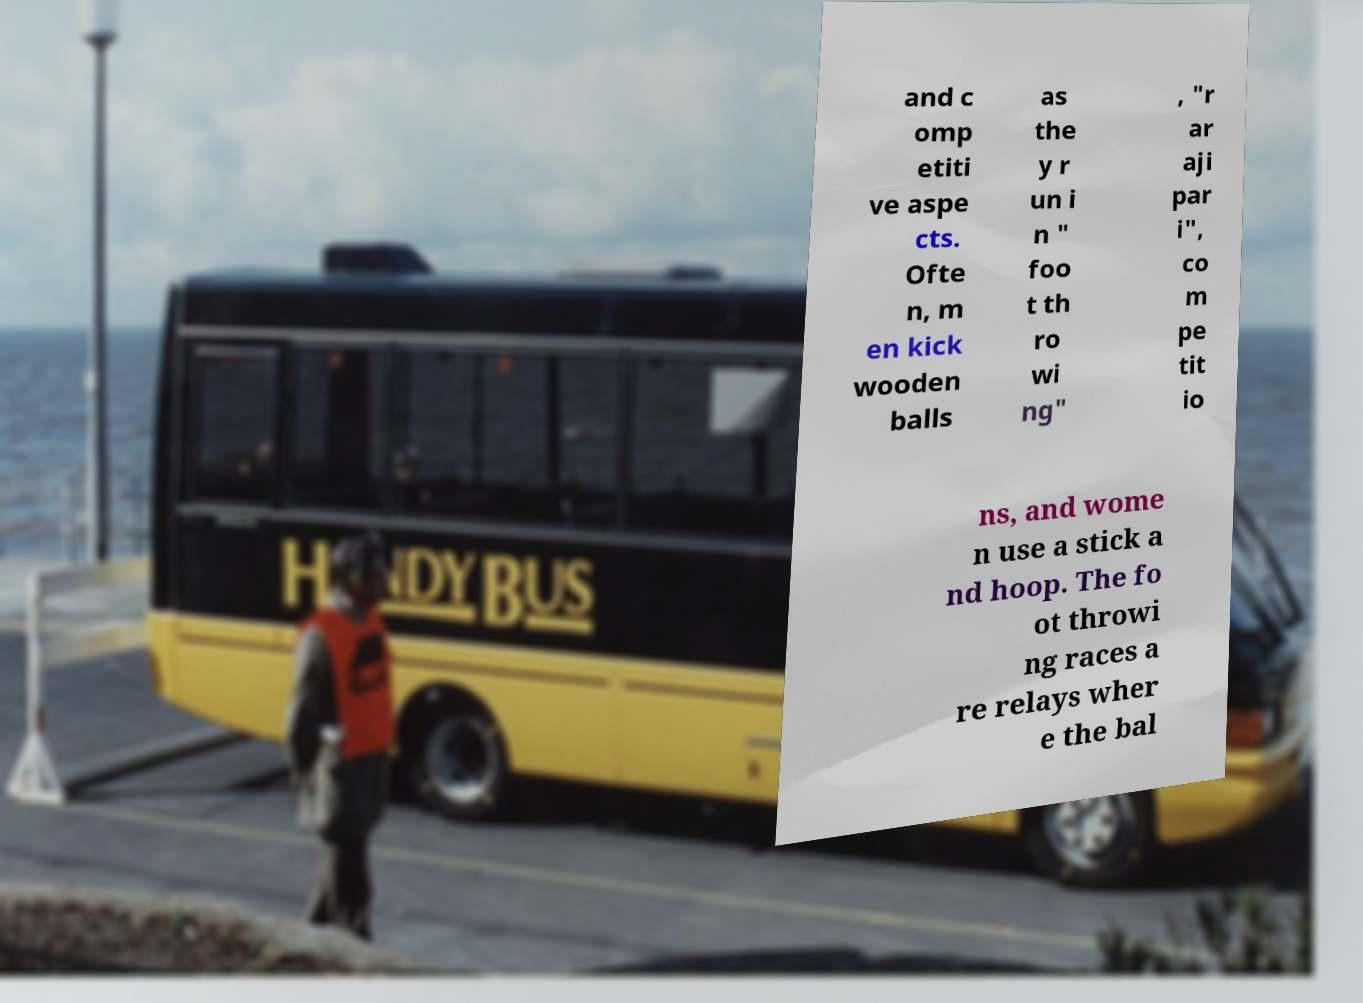Please read and relay the text visible in this image. What does it say? and c omp etiti ve aspe cts. Ofte n, m en kick wooden balls as the y r un i n " foo t th ro wi ng" , "r ar aji par i", co m pe tit io ns, and wome n use a stick a nd hoop. The fo ot throwi ng races a re relays wher e the bal 